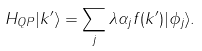Convert formula to latex. <formula><loc_0><loc_0><loc_500><loc_500>H _ { Q P } | k ^ { \prime } \rangle = \sum _ { j } \lambda \alpha _ { j } f ( k ^ { \prime } ) | \phi _ { j } \rangle .</formula> 